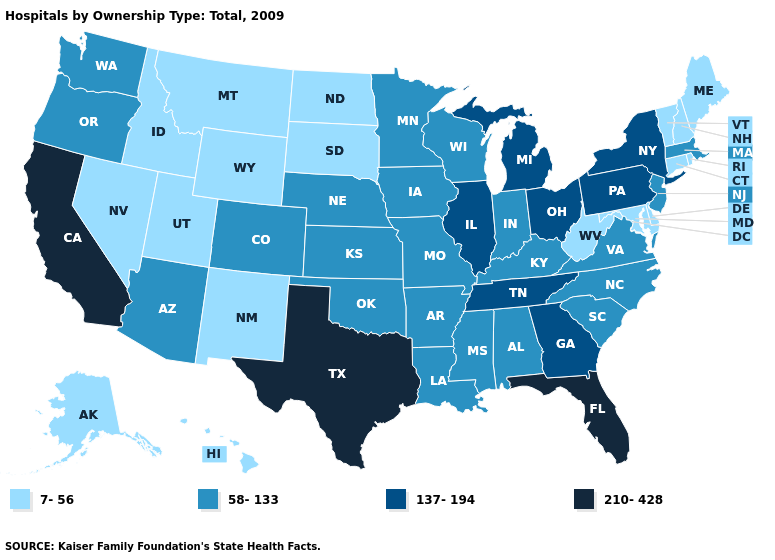Does Louisiana have the highest value in the South?
Quick response, please. No. Name the states that have a value in the range 7-56?
Keep it brief. Alaska, Connecticut, Delaware, Hawaii, Idaho, Maine, Maryland, Montana, Nevada, New Hampshire, New Mexico, North Dakota, Rhode Island, South Dakota, Utah, Vermont, West Virginia, Wyoming. Does Texas have the highest value in the USA?
Keep it brief. Yes. Name the states that have a value in the range 7-56?
Quick response, please. Alaska, Connecticut, Delaware, Hawaii, Idaho, Maine, Maryland, Montana, Nevada, New Hampshire, New Mexico, North Dakota, Rhode Island, South Dakota, Utah, Vermont, West Virginia, Wyoming. Name the states that have a value in the range 137-194?
Write a very short answer. Georgia, Illinois, Michigan, New York, Ohio, Pennsylvania, Tennessee. What is the value of Indiana?
Concise answer only. 58-133. What is the highest value in the South ?
Answer briefly. 210-428. Which states have the lowest value in the MidWest?
Write a very short answer. North Dakota, South Dakota. What is the value of Maryland?
Keep it brief. 7-56. Among the states that border Delaware , which have the lowest value?
Concise answer only. Maryland. Does Vermont have the highest value in the Northeast?
Short answer required. No. What is the value of Minnesota?
Give a very brief answer. 58-133. Which states have the highest value in the USA?
Write a very short answer. California, Florida, Texas. Name the states that have a value in the range 210-428?
Short answer required. California, Florida, Texas. 